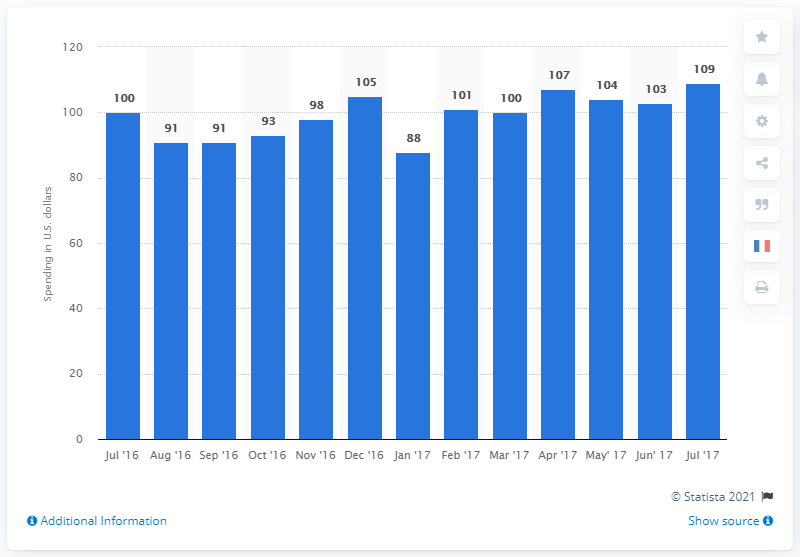Highlight a few significant elements in this photo. In July 2017, the average daily spending of Americans was approximately $109. 